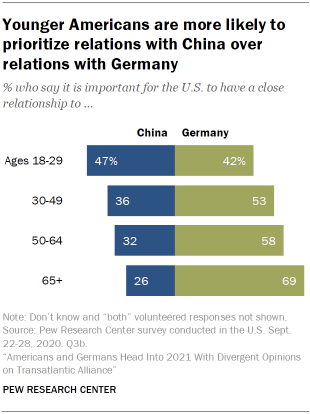Specify some key components in this picture. In China and Germany, the ratio of ages 30-49 is approximately 1.536805556. The chart compares two countries: China and Germany. 